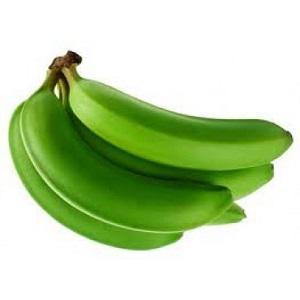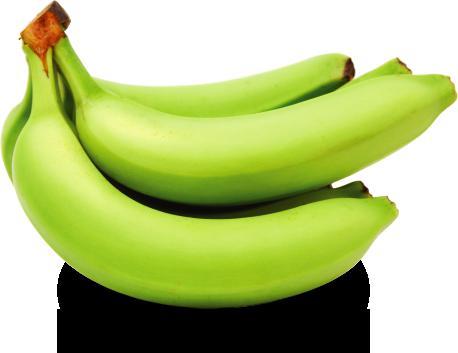The first image is the image on the left, the second image is the image on the right. Evaluate the accuracy of this statement regarding the images: "The left image has at least one banana with it's end facing left, and the right image has a bunch of bananas with it's end facing right.". Is it true? Answer yes or no. No. The first image is the image on the left, the second image is the image on the right. Examine the images to the left and right. Is the description "The ends of the bananas in both pictures are pointing in opposite directions." accurate? Answer yes or no. No. 